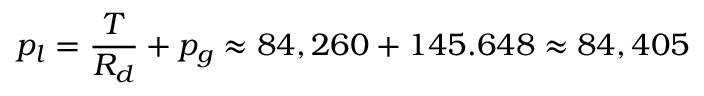<formula> <loc_0><loc_0><loc_500><loc_500>p _ { l } = \frac { T } { R _ { d } } + p _ { g } \approx 8 4 , 2 6 0 + 1 4 5 . 6 4 8 \approx 8 4 , 4 0 5</formula> 